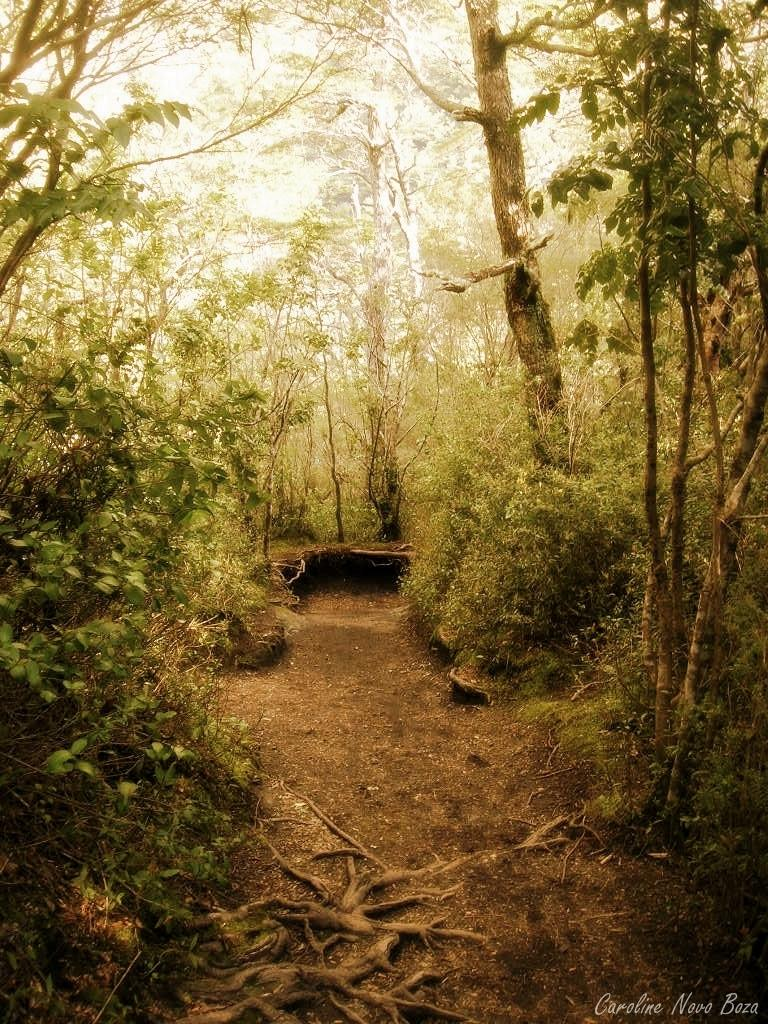What type of vegetation can be seen in the image? There are many trees and plants in the image. What part of the natural environment is visible in the image? The ground is visible in the image. Is there any text or marking in the image? Yes, there is a watermark in the bottom right corner of the image. How many flies can be seen on the trees in the image? There are no flies present in the image; it only features trees and plants. 